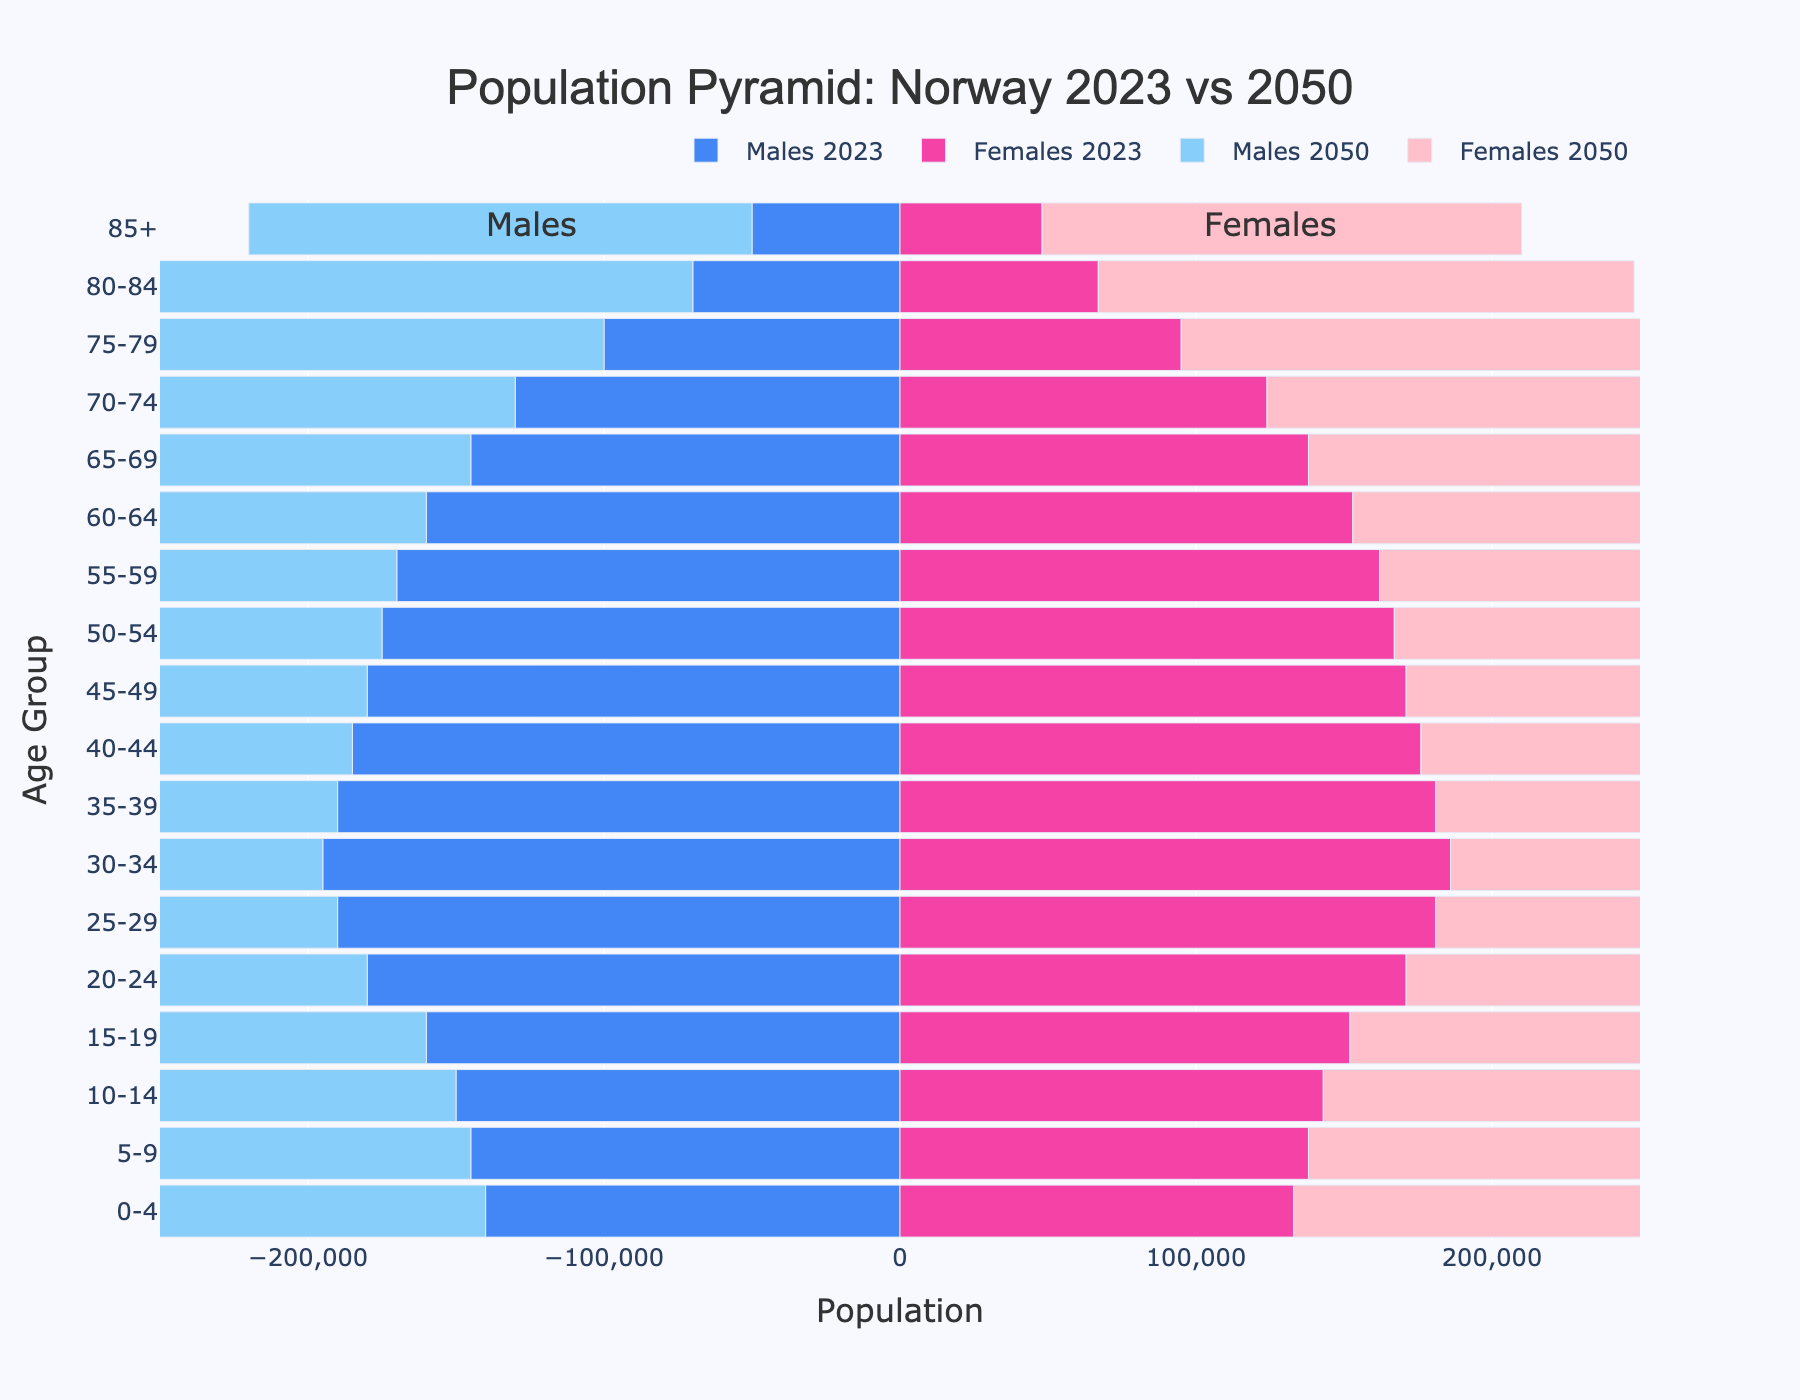What is the title of the figure? The title of the figure is the large text located at the top center of the chart.
Answer: Population Pyramid: Norway 2023 vs 2050 Which age group has the largest projected male population in 2050? Locate the age group with the largest negative bar length for males in 2050. The largest negative bar length represents the age group 65-69.
Answer: 65-69 In 2023, which age group has more females than males? Look for bars where the bar lengths for females are greater than for males in 2023. In this dataset, the age groups 0-4 through 15-19 show females having higher counts than males.
Answer: 0-4, 5-9, 10-14, 15-19 What is the value range for the x-axis? The x-axis value range can be determined from the numerical values shown along the axis. The range is from -250,000 to 250,000.
Answer: -250000 to 250000 Which age group experiences the largest absolute increase in the male population from 2023 to 2050? To find this, calculate the difference between the male populations in 2050 and 2023 for each age group and then take the absolute value. The largest difference is for the age group 75-79.
Answer: 75-79 Compare the projected population distribution for males and females in the age group 50-54 in 2050. Which gender has a higher population, and by how much? For the age group 50-54 in 2050, compare the lengths of the corresponding bars for males and females. Subtract the male population from the female population to find the difference. Females are higher by 201,000 - 210,000 = -9,000.
Answer: Males by 9,000 Which age group has the smallest projected population for both males and females in 2050? Identify the age group with the shortest bars for both males and females in the 2050 dataset. The age group 85+ has the smallest projected population for both genders.
Answer: 85+ How has the population of the age group 70-74 changed from 2023 to 2050 for females? Locate the bar lengths for the age group 70-74 for females in both 2023 and 2050, then subtract the 2023 value from the 2050 value. For females, the population increased by 211,000 - 124,000 = 87,000.
Answer: Increased by 87,000 What is the total population of the age group 30-34 in 2023? Sum the absolute values of males and females in the age group 30-34 for 2023. The total is 195,000 + 186,000 = 381,000.
Answer: 381,000 Which age groups show a consistent increase in both male and female populations from 2023 to 2050? Determine the age groups where both the male and female populations in 2050 are greater than their respective populations in 2023. The age groups 35-39 through 85+ demonstrate a consistent increase for both genders.
Answer: 35-39, 40-44, 45-49, 50-54, 55-59, 60-64, 65-69, 70-74, 75-79, 80-84, 85+ 